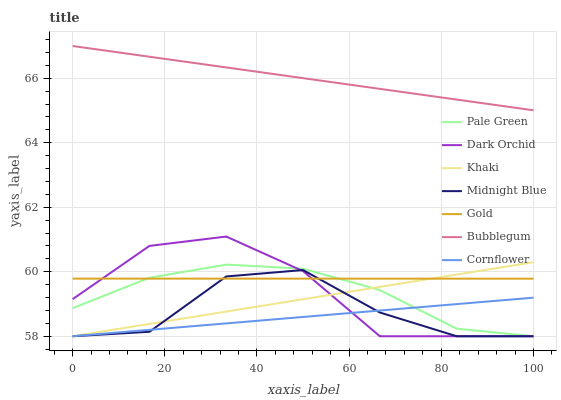Does Cornflower have the minimum area under the curve?
Answer yes or no. Yes. Does Bubblegum have the maximum area under the curve?
Answer yes or no. Yes. Does Khaki have the minimum area under the curve?
Answer yes or no. No. Does Khaki have the maximum area under the curve?
Answer yes or no. No. Is Cornflower the smoothest?
Answer yes or no. Yes. Is Midnight Blue the roughest?
Answer yes or no. Yes. Is Khaki the smoothest?
Answer yes or no. No. Is Khaki the roughest?
Answer yes or no. No. Does Gold have the lowest value?
Answer yes or no. No. Does Bubblegum have the highest value?
Answer yes or no. Yes. Does Khaki have the highest value?
Answer yes or no. No. Is Dark Orchid less than Bubblegum?
Answer yes or no. Yes. Is Gold greater than Cornflower?
Answer yes or no. Yes. Does Dark Orchid intersect Midnight Blue?
Answer yes or no. Yes. Is Dark Orchid less than Midnight Blue?
Answer yes or no. No. Is Dark Orchid greater than Midnight Blue?
Answer yes or no. No. Does Dark Orchid intersect Bubblegum?
Answer yes or no. No. 